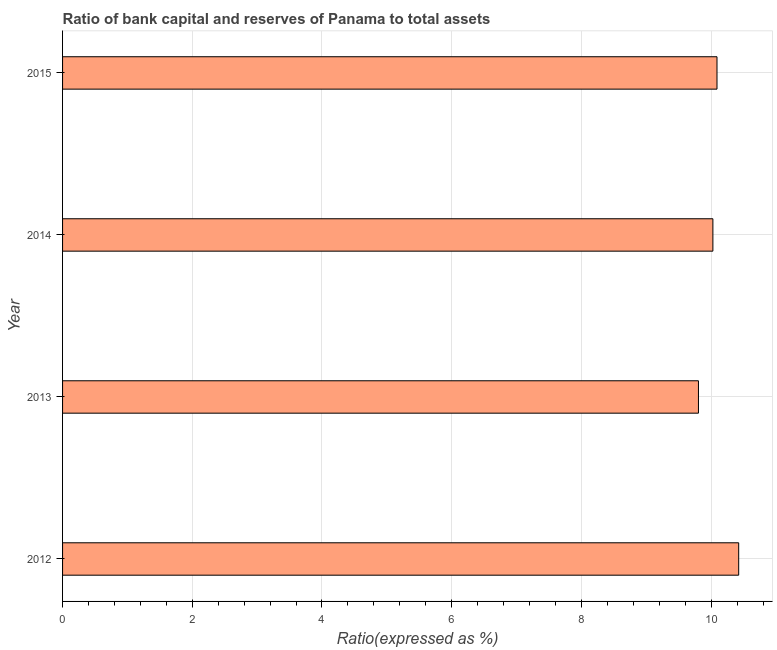What is the title of the graph?
Make the answer very short. Ratio of bank capital and reserves of Panama to total assets. What is the label or title of the X-axis?
Make the answer very short. Ratio(expressed as %). What is the bank capital to assets ratio in 2015?
Offer a very short reply. 10.09. Across all years, what is the maximum bank capital to assets ratio?
Offer a very short reply. 10.42. Across all years, what is the minimum bank capital to assets ratio?
Provide a succinct answer. 9.8. What is the sum of the bank capital to assets ratio?
Provide a succinct answer. 40.35. What is the difference between the bank capital to assets ratio in 2012 and 2013?
Your answer should be compact. 0.62. What is the average bank capital to assets ratio per year?
Make the answer very short. 10.09. What is the median bank capital to assets ratio?
Give a very brief answer. 10.06. In how many years, is the bank capital to assets ratio greater than 5.6 %?
Offer a terse response. 4. Do a majority of the years between 2015 and 2013 (inclusive) have bank capital to assets ratio greater than 4 %?
Offer a very short reply. Yes. What is the ratio of the bank capital to assets ratio in 2012 to that in 2015?
Provide a short and direct response. 1.03. Is the bank capital to assets ratio in 2014 less than that in 2015?
Ensure brevity in your answer.  Yes. Is the difference between the bank capital to assets ratio in 2012 and 2014 greater than the difference between any two years?
Make the answer very short. No. What is the difference between the highest and the second highest bank capital to assets ratio?
Your answer should be compact. 0.33. Is the sum of the bank capital to assets ratio in 2013 and 2015 greater than the maximum bank capital to assets ratio across all years?
Provide a short and direct response. Yes. What is the difference between the highest and the lowest bank capital to assets ratio?
Make the answer very short. 0.62. How many years are there in the graph?
Ensure brevity in your answer.  4. What is the Ratio(expressed as %) in 2012?
Your answer should be compact. 10.42. What is the Ratio(expressed as %) in 2013?
Offer a very short reply. 9.8. What is the Ratio(expressed as %) of 2014?
Provide a short and direct response. 10.03. What is the Ratio(expressed as %) of 2015?
Your response must be concise. 10.09. What is the difference between the Ratio(expressed as %) in 2012 and 2013?
Offer a very short reply. 0.62. What is the difference between the Ratio(expressed as %) in 2012 and 2014?
Ensure brevity in your answer.  0.4. What is the difference between the Ratio(expressed as %) in 2012 and 2015?
Provide a succinct answer. 0.33. What is the difference between the Ratio(expressed as %) in 2013 and 2014?
Your response must be concise. -0.22. What is the difference between the Ratio(expressed as %) in 2013 and 2015?
Offer a terse response. -0.29. What is the difference between the Ratio(expressed as %) in 2014 and 2015?
Your answer should be very brief. -0.06. What is the ratio of the Ratio(expressed as %) in 2012 to that in 2013?
Ensure brevity in your answer.  1.06. What is the ratio of the Ratio(expressed as %) in 2012 to that in 2014?
Provide a succinct answer. 1.04. What is the ratio of the Ratio(expressed as %) in 2012 to that in 2015?
Offer a terse response. 1.03. What is the ratio of the Ratio(expressed as %) in 2013 to that in 2014?
Offer a terse response. 0.98. 